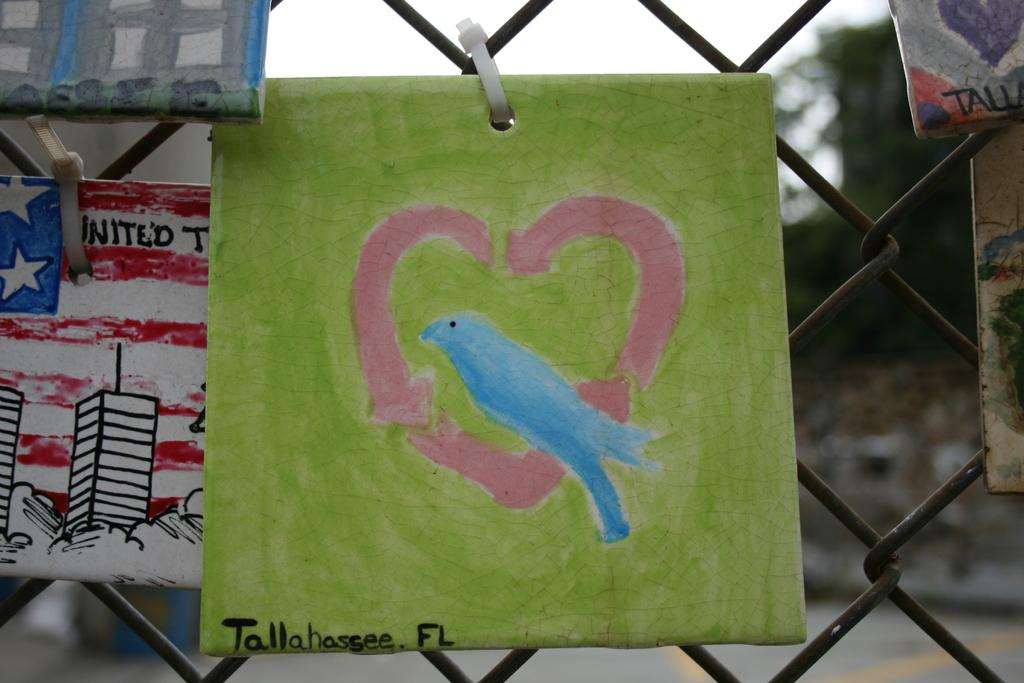What type of artwork can be seen in the image? There are wall paintings in the image. What other object is visible in the image? There is a fence in the image. What can be seen in the background of the image? The sky and trees are visible in the background of the image. When was the image taken? The image was taken during the day. What word is written on the bed in the image? There is no bed present in the image, so no word can be written on it. 